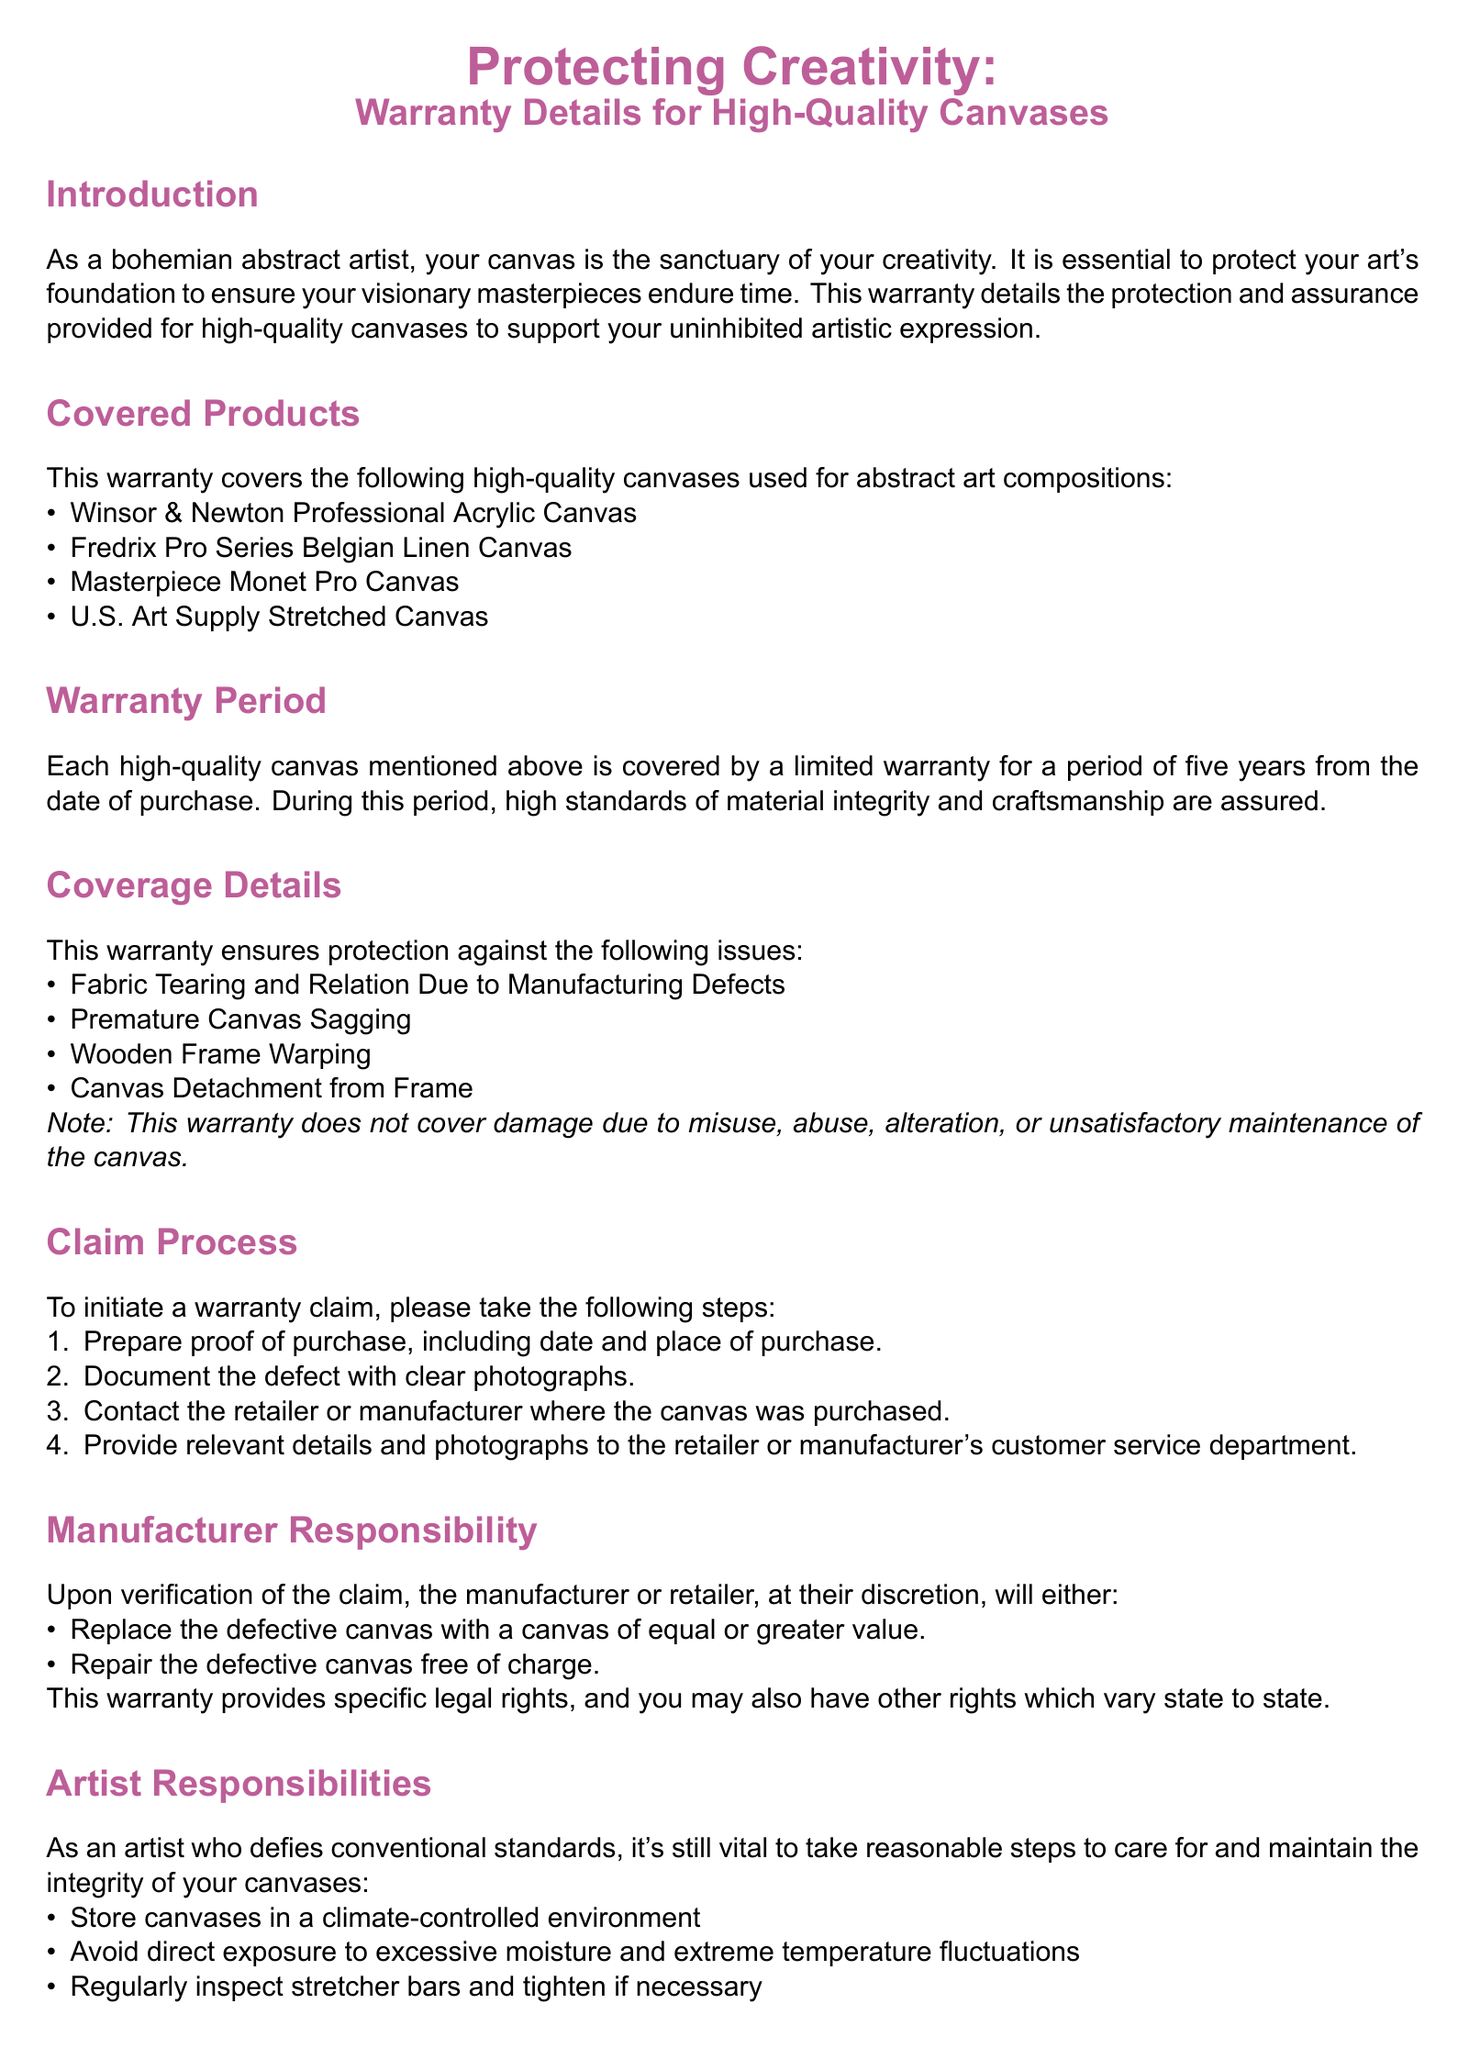What is the warranty period? The warranty period for the high-quality canvases is stated clearly in the document as five years from the date of purchase.
Answer: Five years Which canvases are covered by this warranty? The document lists specific high-quality canvases that are covered, including Winsor & Newton Professional Acrylic Canvas and others.
Answer: Winsor & Newton Professional Acrylic Canvas, Fredrix Pro Series Belgian Linen Canvas, Masterpiece Monet Pro Canvas, U.S. Art Supply Stretched Canvas What are the coverage details for the warranty? The document outlines specific issues that the warranty covers, providing a clear list of coverage details.
Answer: Fabric Tearing, Premature Canvas Sagging, Wooden Frame Warping, Canvas Detachment from Frame What is required to initiate a warranty claim? The document details a specific process for initiating a claim, which includes preparing proof of purchase and documenting defects.
Answer: Prepare proof of purchase, document the defect with clear photographs Who is responsible for repairing or replacing the defective canvas? According to the document, the manufacturer or retailer is responsible for verifying claims and deciding whether to repair or replace.
Answer: Manufacturer or retailer What are the artist's responsibilities regarding canvas care? The warranty provides a list of responsibilities for artists that includes storing canvases in a climate-controlled environment and inspecting stretcher bars.
Answer: Store canvases in a climate-controlled environment, avoid direct exposure to excessive moisture and extreme temperature fluctuations What should one do if they have questions about the warranty? The document provides contact information for various manufacturers regarding questions or defects related to the warranty.
Answer: Contact Winsor & Newton, Fredrix, Masterpiece Artist Canvas, U.S. Art Supply What damages are excluded from the warranty? The document mentions limitations on liability, specifically stating that indirect, special, incidental, or consequential damages are not covered.
Answer: Indirect, special, incidental, or consequential damages 